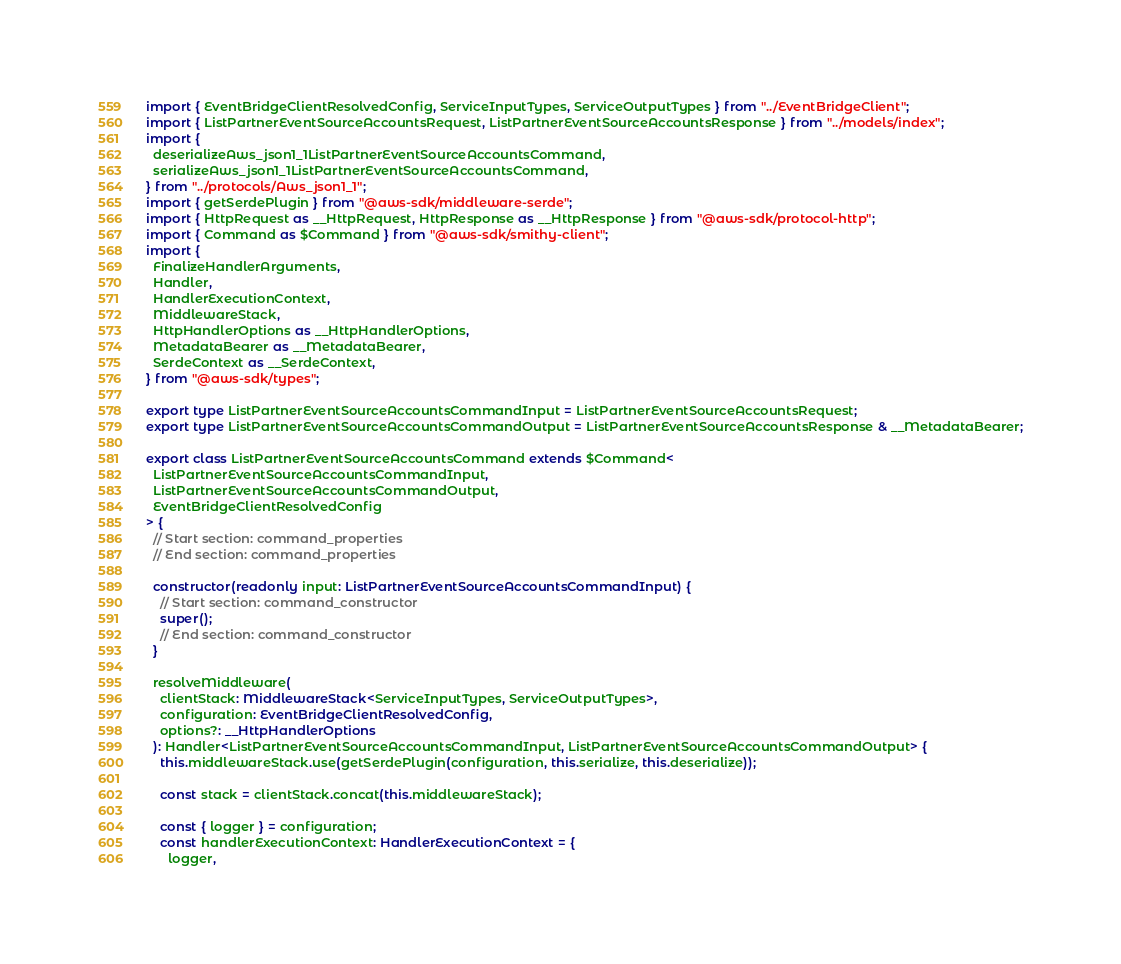<code> <loc_0><loc_0><loc_500><loc_500><_TypeScript_>import { EventBridgeClientResolvedConfig, ServiceInputTypes, ServiceOutputTypes } from "../EventBridgeClient";
import { ListPartnerEventSourceAccountsRequest, ListPartnerEventSourceAccountsResponse } from "../models/index";
import {
  deserializeAws_json1_1ListPartnerEventSourceAccountsCommand,
  serializeAws_json1_1ListPartnerEventSourceAccountsCommand,
} from "../protocols/Aws_json1_1";
import { getSerdePlugin } from "@aws-sdk/middleware-serde";
import { HttpRequest as __HttpRequest, HttpResponse as __HttpResponse } from "@aws-sdk/protocol-http";
import { Command as $Command } from "@aws-sdk/smithy-client";
import {
  FinalizeHandlerArguments,
  Handler,
  HandlerExecutionContext,
  MiddlewareStack,
  HttpHandlerOptions as __HttpHandlerOptions,
  MetadataBearer as __MetadataBearer,
  SerdeContext as __SerdeContext,
} from "@aws-sdk/types";

export type ListPartnerEventSourceAccountsCommandInput = ListPartnerEventSourceAccountsRequest;
export type ListPartnerEventSourceAccountsCommandOutput = ListPartnerEventSourceAccountsResponse & __MetadataBearer;

export class ListPartnerEventSourceAccountsCommand extends $Command<
  ListPartnerEventSourceAccountsCommandInput,
  ListPartnerEventSourceAccountsCommandOutput,
  EventBridgeClientResolvedConfig
> {
  // Start section: command_properties
  // End section: command_properties

  constructor(readonly input: ListPartnerEventSourceAccountsCommandInput) {
    // Start section: command_constructor
    super();
    // End section: command_constructor
  }

  resolveMiddleware(
    clientStack: MiddlewareStack<ServiceInputTypes, ServiceOutputTypes>,
    configuration: EventBridgeClientResolvedConfig,
    options?: __HttpHandlerOptions
  ): Handler<ListPartnerEventSourceAccountsCommandInput, ListPartnerEventSourceAccountsCommandOutput> {
    this.middlewareStack.use(getSerdePlugin(configuration, this.serialize, this.deserialize));

    const stack = clientStack.concat(this.middlewareStack);

    const { logger } = configuration;
    const handlerExecutionContext: HandlerExecutionContext = {
      logger,</code> 